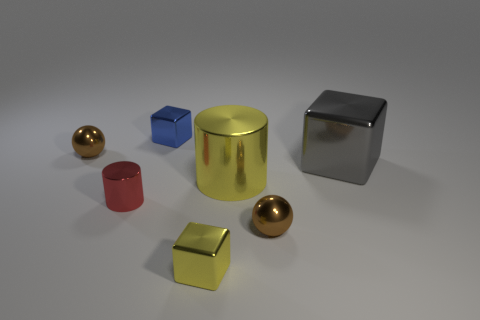Subtract all green blocks. Subtract all cyan spheres. How many blocks are left? 3 Add 1 metal balls. How many objects exist? 8 Subtract all blocks. How many objects are left? 4 Add 3 small brown metallic things. How many small brown metallic things are left? 5 Add 4 tiny yellow shiny blocks. How many tiny yellow shiny blocks exist? 5 Subtract 0 green cubes. How many objects are left? 7 Subtract all metallic objects. Subtract all large green metallic things. How many objects are left? 0 